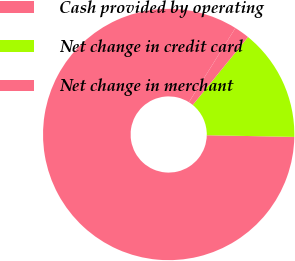Convert chart. <chart><loc_0><loc_0><loc_500><loc_500><pie_chart><fcel>Cash provided by operating<fcel>Net change in credit card<fcel>Net change in merchant<nl><fcel>83.6%<fcel>14.43%<fcel>1.97%<nl></chart> 